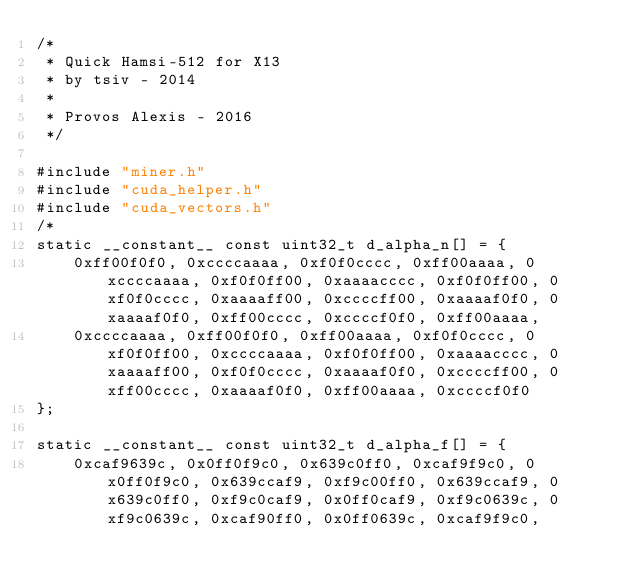<code> <loc_0><loc_0><loc_500><loc_500><_Cuda_>/*
 * Quick Hamsi-512 for X13
 * by tsiv - 2014
 *
 * Provos Alexis - 2016
 */

#include "miner.h"
#include "cuda_helper.h"
#include "cuda_vectors.h"
/*
static __constant__ const uint32_t d_alpha_n[] = {
	0xff00f0f0, 0xccccaaaa, 0xf0f0cccc, 0xff00aaaa, 0xccccaaaa, 0xf0f0ff00, 0xaaaacccc, 0xf0f0ff00,	0xf0f0cccc, 0xaaaaff00, 0xccccff00, 0xaaaaf0f0, 0xaaaaf0f0, 0xff00cccc, 0xccccf0f0, 0xff00aaaa,
	0xccccaaaa, 0xff00f0f0, 0xff00aaaa, 0xf0f0cccc, 0xf0f0ff00, 0xccccaaaa, 0xf0f0ff00, 0xaaaacccc,	0xaaaaff00, 0xf0f0cccc, 0xaaaaf0f0, 0xccccff00, 0xff00cccc, 0xaaaaf0f0, 0xff00aaaa, 0xccccf0f0
};

static __constant__ const uint32_t d_alpha_f[] = {
	0xcaf9639c, 0x0ff0f9c0, 0x639c0ff0, 0xcaf9f9c0, 0x0ff0f9c0, 0x639ccaf9, 0xf9c00ff0, 0x639ccaf9,	0x639c0ff0, 0xf9c0caf9, 0x0ff0caf9, 0xf9c0639c, 0xf9c0639c, 0xcaf90ff0, 0x0ff0639c, 0xcaf9f9c0,</code> 